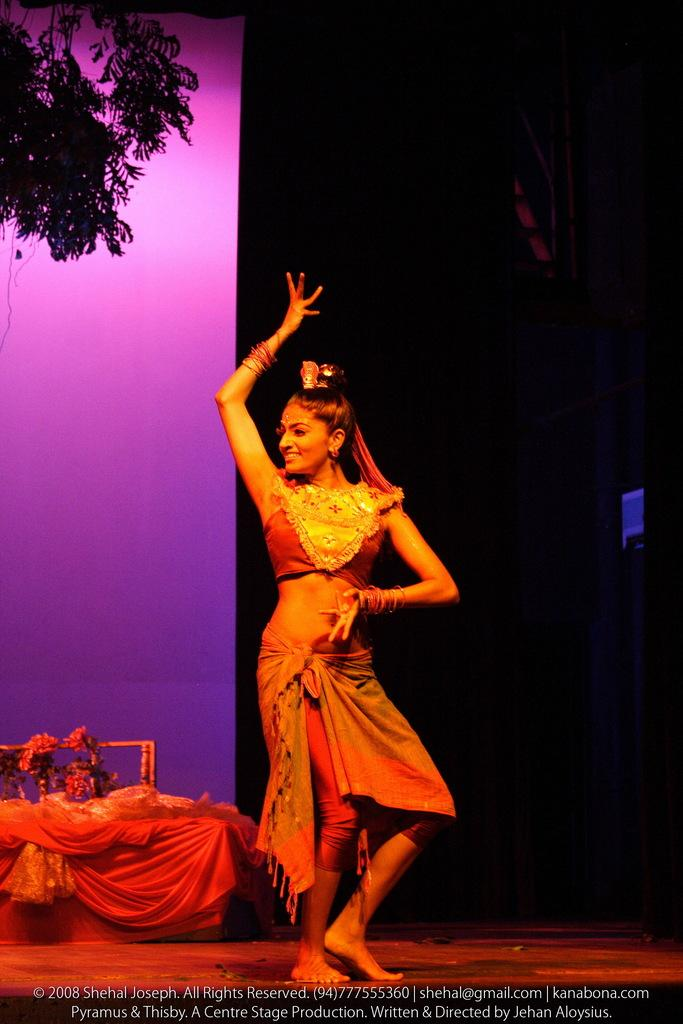Who is present in the image? There is a woman in the image. What is the woman doing in the image? The woman is standing on a surface and smiling. What type of vegetation can be seen in the image? There are flowers and leaves visible in the image. What type of material is visible in the image? There is cloth visible in the image. What else can be seen in the image besides the woman and vegetation? There are objects visible in the image. How would you describe the overall lighting in the image? The background of the image is dark. What type of sign can be seen in the image? There is no sign present in the image. What is the woman using to balance on the rod in the image? There is no rod or balancing act depicted in the image; the woman is simply standing on a surface. 